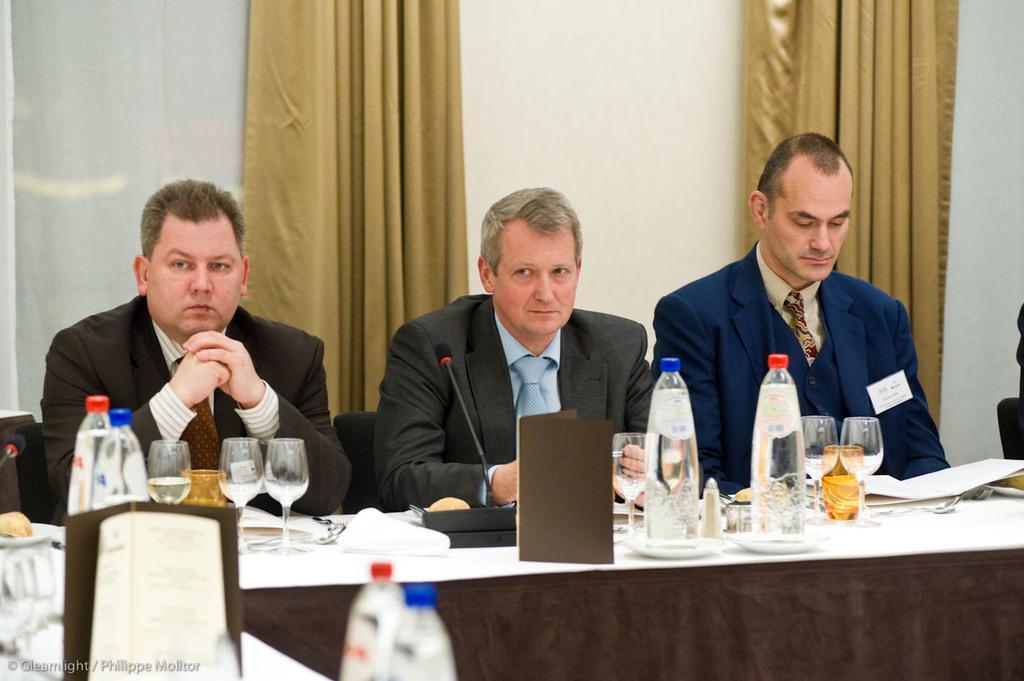Can you describe this image briefly? In the center of the image we can see a group of people. In the foreground we can see group of glasses, books, bottles, books and a microphone placed on the table. In the bottom left corner of the image we can see some text. In the background, we can see the curtains. 